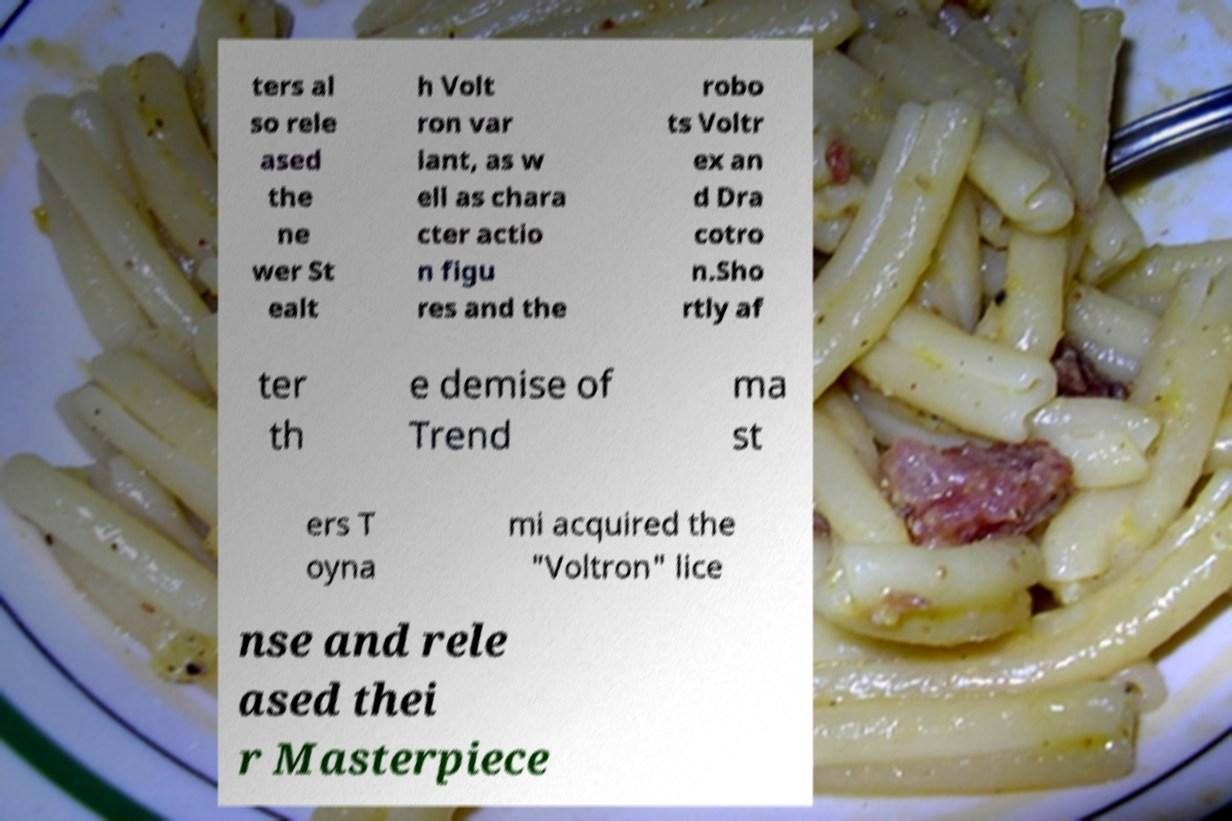Could you assist in decoding the text presented in this image and type it out clearly? ters al so rele ased the ne wer St ealt h Volt ron var iant, as w ell as chara cter actio n figu res and the robo ts Voltr ex an d Dra cotro n.Sho rtly af ter th e demise of Trend ma st ers T oyna mi acquired the "Voltron" lice nse and rele ased thei r Masterpiece 